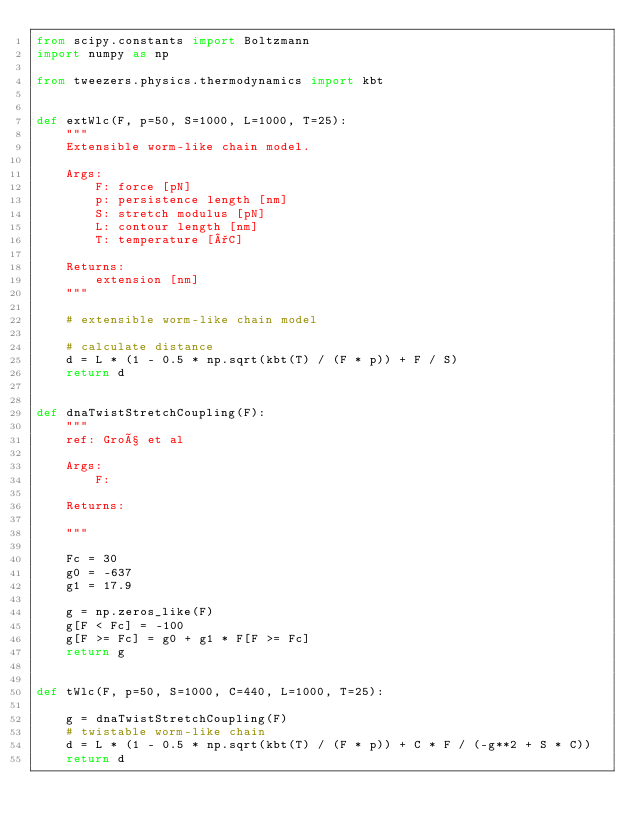Convert code to text. <code><loc_0><loc_0><loc_500><loc_500><_Python_>from scipy.constants import Boltzmann
import numpy as np

from tweezers.physics.thermodynamics import kbt


def extWlc(F, p=50, S=1000, L=1000, T=25):
    """
    Extensible worm-like chain model.

    Args:
        F: force [pN]
        p: persistence length [nm]
        S: stretch modulus [pN]
        L: contour length [nm]
        T: temperature [°C]

    Returns:
        extension [nm]
    """

    # extensible worm-like chain model

    # calculate distance
    d = L * (1 - 0.5 * np.sqrt(kbt(T) / (F * p)) + F / S)
    return d


def dnaTwistStretchCoupling(F):
    """
    ref: Groß et al

    Args:
        F:

    Returns:

    """

    Fc = 30
    g0 = -637
    g1 = 17.9

    g = np.zeros_like(F)
    g[F < Fc] = -100
    g[F >= Fc] = g0 + g1 * F[F >= Fc]
    return g


def tWlc(F, p=50, S=1000, C=440, L=1000, T=25):

    g = dnaTwistStretchCoupling(F)
    # twistable worm-like chain
    d = L * (1 - 0.5 * np.sqrt(kbt(T) / (F * p)) + C * F / (-g**2 + S * C))
    return d
</code> 